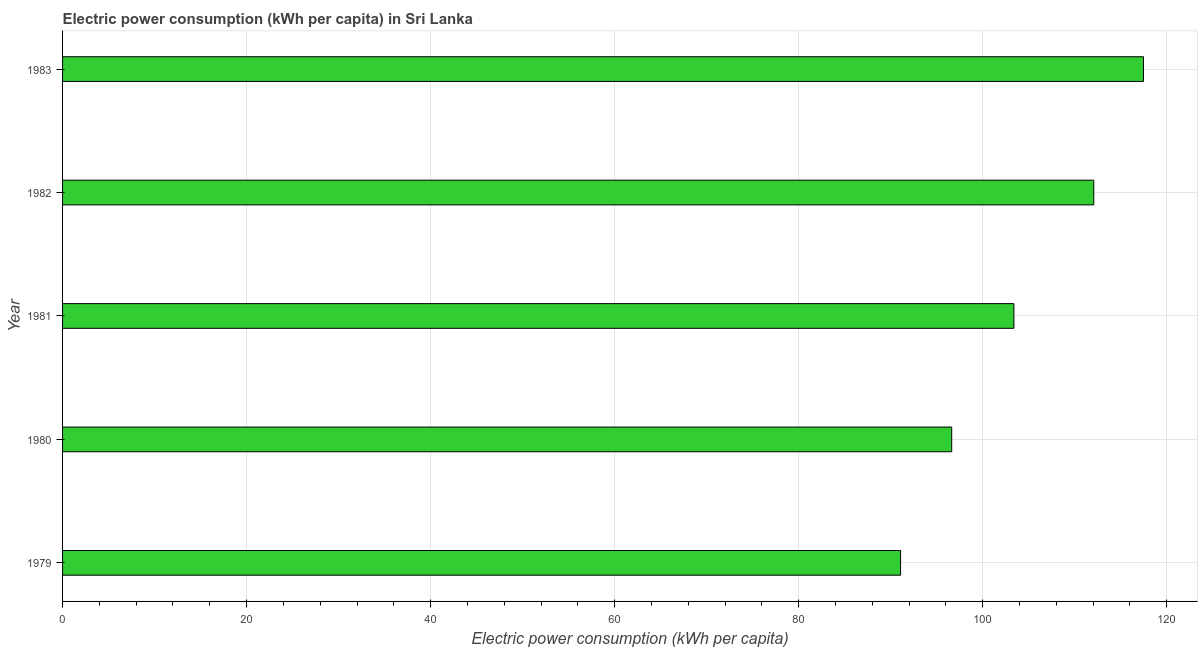Does the graph contain any zero values?
Provide a succinct answer. No. Does the graph contain grids?
Provide a succinct answer. Yes. What is the title of the graph?
Your response must be concise. Electric power consumption (kWh per capita) in Sri Lanka. What is the label or title of the X-axis?
Provide a short and direct response. Electric power consumption (kWh per capita). What is the label or title of the Y-axis?
Ensure brevity in your answer.  Year. What is the electric power consumption in 1982?
Make the answer very short. 112.07. Across all years, what is the maximum electric power consumption?
Your response must be concise. 117.47. Across all years, what is the minimum electric power consumption?
Offer a terse response. 91.07. In which year was the electric power consumption maximum?
Give a very brief answer. 1983. In which year was the electric power consumption minimum?
Your answer should be compact. 1979. What is the sum of the electric power consumption?
Provide a succinct answer. 520.63. What is the difference between the electric power consumption in 1981 and 1983?
Your answer should be compact. -14.08. What is the average electric power consumption per year?
Keep it short and to the point. 104.12. What is the median electric power consumption?
Offer a terse response. 103.39. In how many years, is the electric power consumption greater than 28 kWh per capita?
Provide a short and direct response. 5. Do a majority of the years between 1982 and 1980 (inclusive) have electric power consumption greater than 64 kWh per capita?
Give a very brief answer. Yes. What is the ratio of the electric power consumption in 1979 to that in 1981?
Provide a succinct answer. 0.88. Is the difference between the electric power consumption in 1981 and 1982 greater than the difference between any two years?
Provide a succinct answer. No. What is the difference between the highest and the second highest electric power consumption?
Make the answer very short. 5.4. Is the sum of the electric power consumption in 1980 and 1983 greater than the maximum electric power consumption across all years?
Ensure brevity in your answer.  Yes. What is the difference between the highest and the lowest electric power consumption?
Your answer should be very brief. 26.4. In how many years, is the electric power consumption greater than the average electric power consumption taken over all years?
Offer a terse response. 2. How many years are there in the graph?
Give a very brief answer. 5. Are the values on the major ticks of X-axis written in scientific E-notation?
Offer a very short reply. No. What is the Electric power consumption (kWh per capita) in 1979?
Ensure brevity in your answer.  91.07. What is the Electric power consumption (kWh per capita) of 1980?
Keep it short and to the point. 96.63. What is the Electric power consumption (kWh per capita) in 1981?
Offer a terse response. 103.39. What is the Electric power consumption (kWh per capita) of 1982?
Provide a short and direct response. 112.07. What is the Electric power consumption (kWh per capita) of 1983?
Provide a short and direct response. 117.47. What is the difference between the Electric power consumption (kWh per capita) in 1979 and 1980?
Make the answer very short. -5.56. What is the difference between the Electric power consumption (kWh per capita) in 1979 and 1981?
Make the answer very short. -12.32. What is the difference between the Electric power consumption (kWh per capita) in 1979 and 1982?
Keep it short and to the point. -21. What is the difference between the Electric power consumption (kWh per capita) in 1979 and 1983?
Keep it short and to the point. -26.4. What is the difference between the Electric power consumption (kWh per capita) in 1980 and 1981?
Offer a very short reply. -6.76. What is the difference between the Electric power consumption (kWh per capita) in 1980 and 1982?
Make the answer very short. -15.44. What is the difference between the Electric power consumption (kWh per capita) in 1980 and 1983?
Keep it short and to the point. -20.84. What is the difference between the Electric power consumption (kWh per capita) in 1981 and 1982?
Ensure brevity in your answer.  -8.68. What is the difference between the Electric power consumption (kWh per capita) in 1981 and 1983?
Offer a very short reply. -14.08. What is the difference between the Electric power consumption (kWh per capita) in 1982 and 1983?
Keep it short and to the point. -5.4. What is the ratio of the Electric power consumption (kWh per capita) in 1979 to that in 1980?
Your response must be concise. 0.94. What is the ratio of the Electric power consumption (kWh per capita) in 1979 to that in 1981?
Offer a very short reply. 0.88. What is the ratio of the Electric power consumption (kWh per capita) in 1979 to that in 1982?
Make the answer very short. 0.81. What is the ratio of the Electric power consumption (kWh per capita) in 1979 to that in 1983?
Provide a short and direct response. 0.78. What is the ratio of the Electric power consumption (kWh per capita) in 1980 to that in 1981?
Offer a terse response. 0.94. What is the ratio of the Electric power consumption (kWh per capita) in 1980 to that in 1982?
Provide a short and direct response. 0.86. What is the ratio of the Electric power consumption (kWh per capita) in 1980 to that in 1983?
Keep it short and to the point. 0.82. What is the ratio of the Electric power consumption (kWh per capita) in 1981 to that in 1982?
Your answer should be very brief. 0.92. What is the ratio of the Electric power consumption (kWh per capita) in 1982 to that in 1983?
Provide a succinct answer. 0.95. 